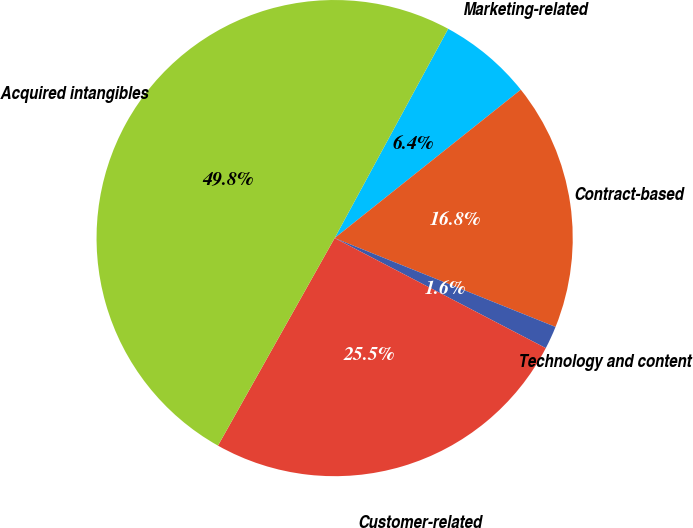Convert chart. <chart><loc_0><loc_0><loc_500><loc_500><pie_chart><fcel>Marketing-related<fcel>Contract-based<fcel>Technology and content<fcel>Customer-related<fcel>Acquired intangibles<nl><fcel>6.38%<fcel>16.8%<fcel>1.56%<fcel>25.51%<fcel>49.77%<nl></chart> 